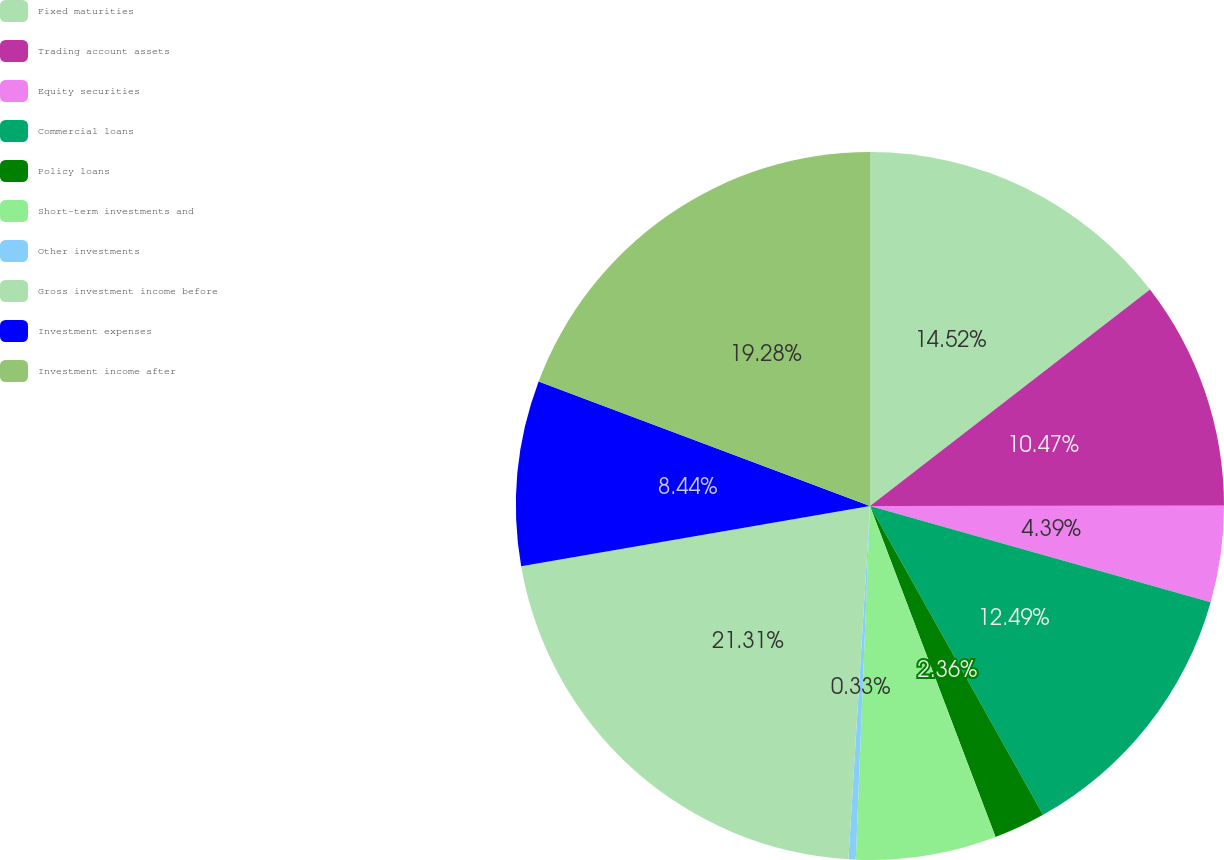Convert chart. <chart><loc_0><loc_0><loc_500><loc_500><pie_chart><fcel>Fixed maturities<fcel>Trading account assets<fcel>Equity securities<fcel>Commercial loans<fcel>Policy loans<fcel>Short-term investments and<fcel>Other investments<fcel>Gross investment income before<fcel>Investment expenses<fcel>Investment income after<nl><fcel>14.52%<fcel>10.47%<fcel>4.39%<fcel>12.49%<fcel>2.36%<fcel>6.41%<fcel>0.33%<fcel>21.31%<fcel>8.44%<fcel>19.28%<nl></chart> 